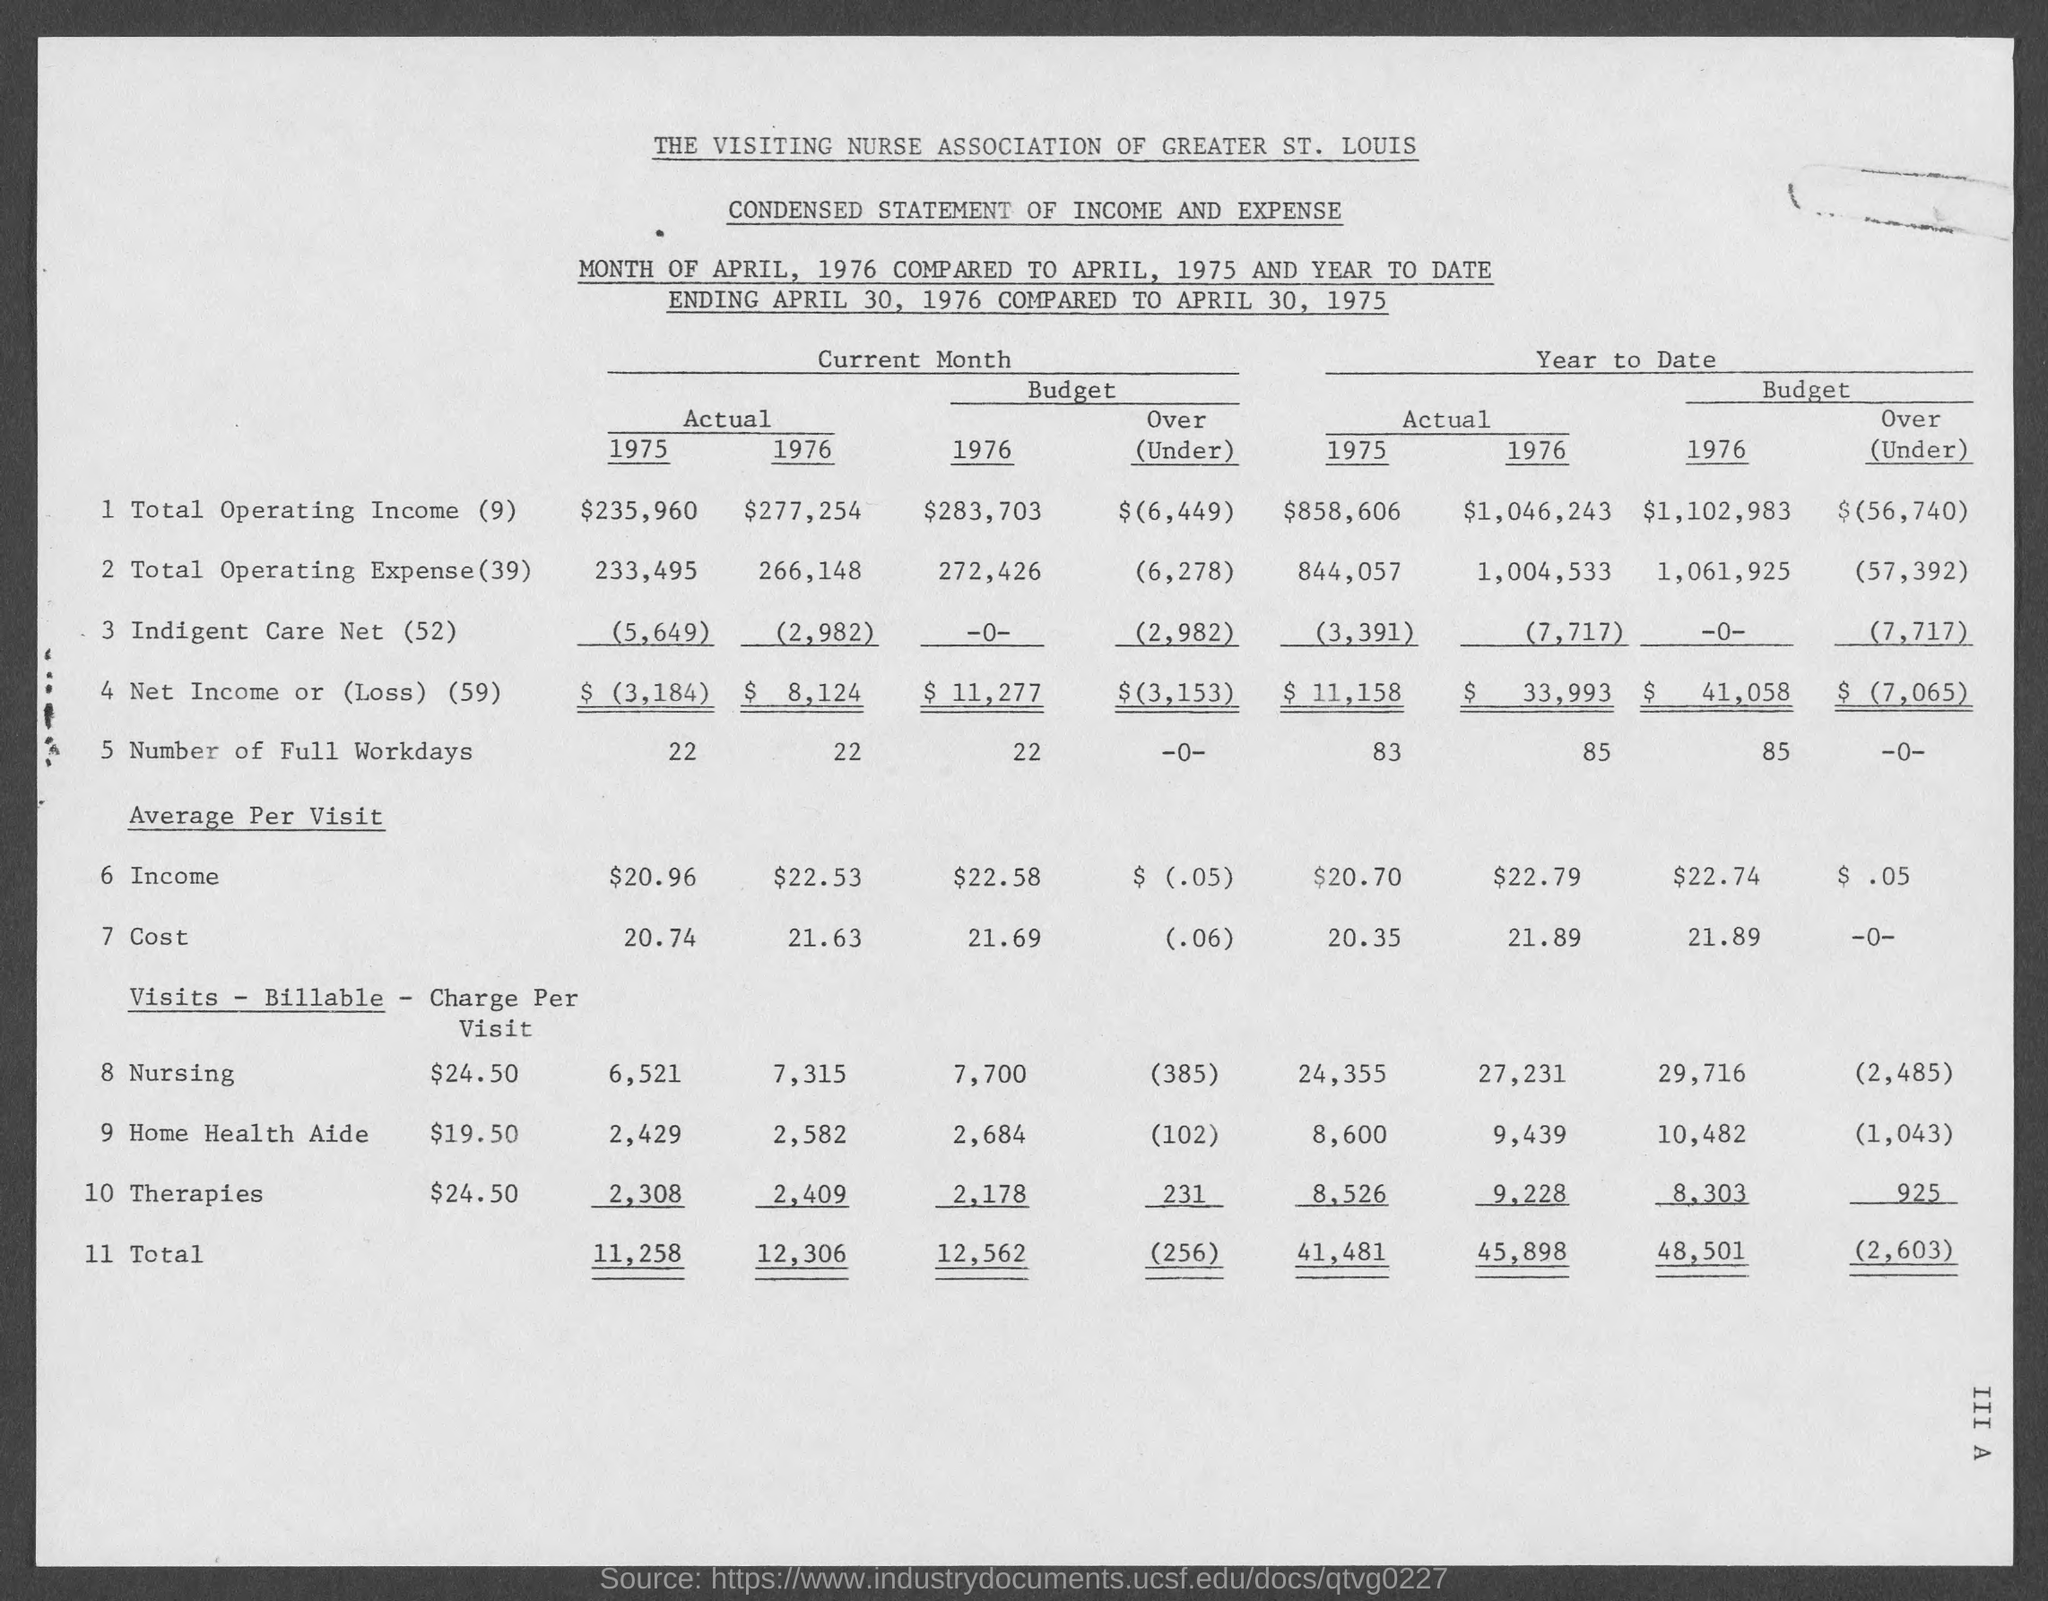What is the Actual Total Operating income for 1975 for current month?
Provide a succinct answer. 235,960. What is the Actual Total Operating income for 1976 for current month?
Your answer should be very brief. $277,254. What is the Budget Total Operating income for 1976 for current month?
Provide a short and direct response. 283,703. What is the Actual Total Operating Expense for 1975 for current month?
Keep it short and to the point. 233,495. What is the Actual Total Operating Expense for 1976 for current month?
Your response must be concise. 266,148. What is the Budget Total Operating Expense for 1976 for current month?
Provide a short and direct response. 272,426. What is the Actual Number of full workdays for 1975 for current month?
Ensure brevity in your answer.  22. What is the  Actual Number of full workdays for 1976 for current month?
Your answer should be compact. 22. What is the Budget Number of full workdays for 1976 for current month?
Your response must be concise. 22. What is the Actual Total for 1975 for current month?
Your answer should be compact. 11,258. 